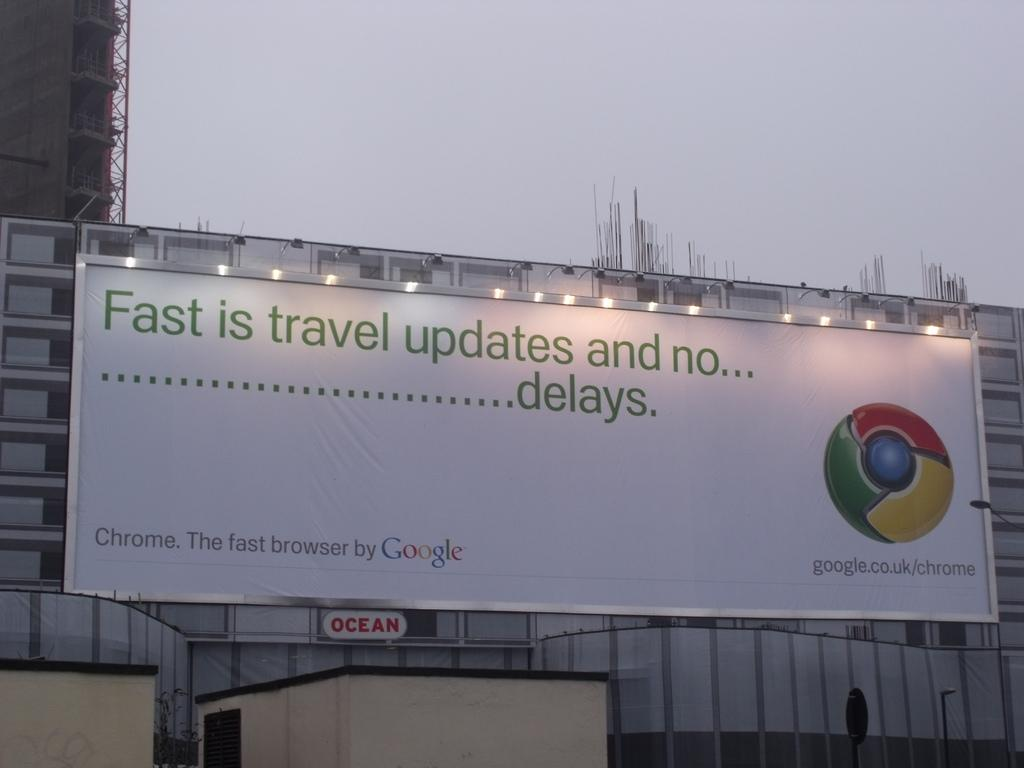What is located in the middle of the image? There is a banner in the middle of the image. What is featured on the banner? The banner contains text and a logo. What can be seen in the image besides the banner? There are lights in the image. What is visible in the background of the image? There are buildings and the sky in the background of the image. What type of stamp can be seen on the banner in the image? There is no stamp present on the banner in the image. What mode of transportation is used for the journey depicted in the image? There is no journey depicted in the image, only a banner with text and a logo. 